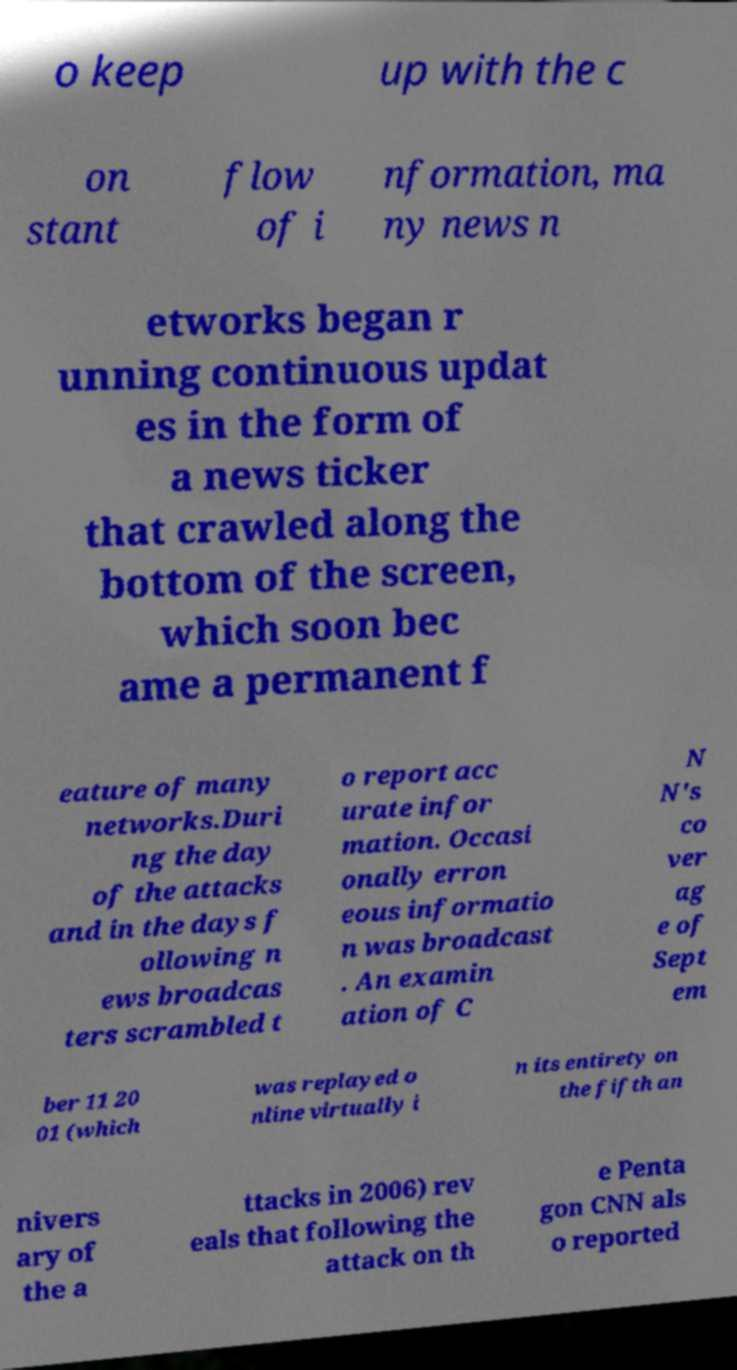I need the written content from this picture converted into text. Can you do that? o keep up with the c on stant flow of i nformation, ma ny news n etworks began r unning continuous updat es in the form of a news ticker that crawled along the bottom of the screen, which soon bec ame a permanent f eature of many networks.Duri ng the day of the attacks and in the days f ollowing n ews broadcas ters scrambled t o report acc urate infor mation. Occasi onally erron eous informatio n was broadcast . An examin ation of C N N's co ver ag e of Sept em ber 11 20 01 (which was replayed o nline virtually i n its entirety on the fifth an nivers ary of the a ttacks in 2006) rev eals that following the attack on th e Penta gon CNN als o reported 